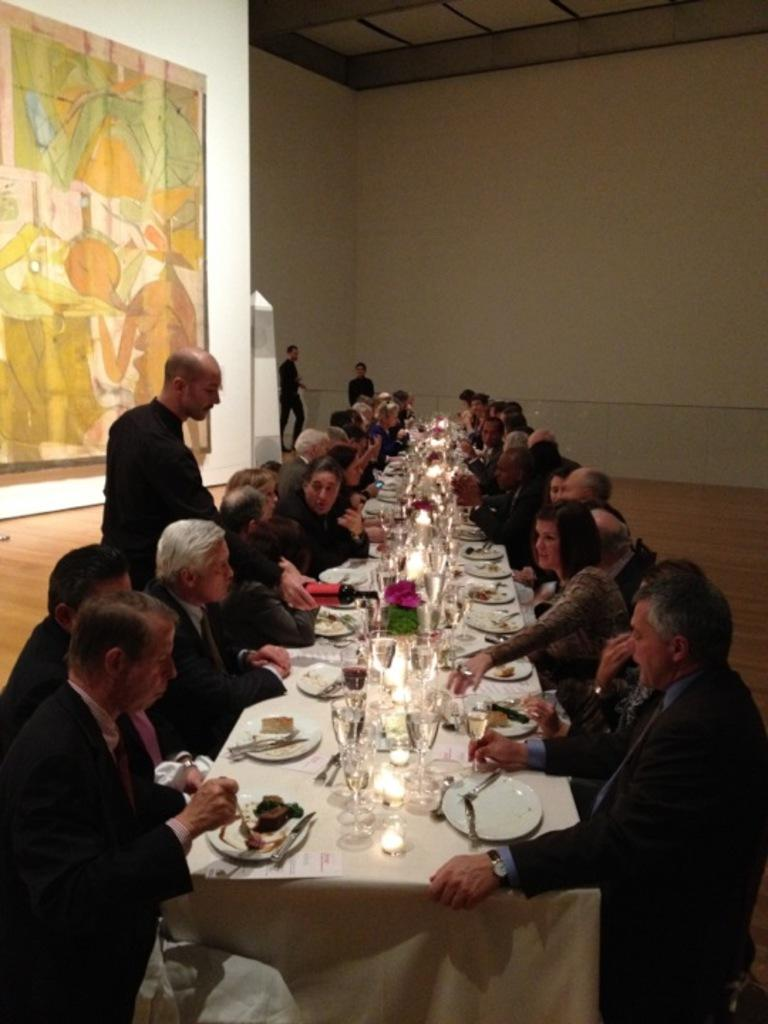How many people are in the image? There is a group of people in the image, but the exact number cannot be determined from the provided facts. What are the people doing in the image? The people are sitting in front of a table. What can be found on the table in the image? There are eatables and drinks on the table. What type of tax is being discussed by the people in the image? There is no indication in the image that the people are discussing any type of tax. 